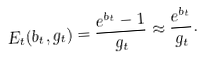<formula> <loc_0><loc_0><loc_500><loc_500>E _ { t } ( b _ { t } , g _ { t } ) = \frac { e ^ { b _ { t } } - 1 } { g _ { t } } \approx \frac { e ^ { b _ { t } } } { g _ { t } } .</formula> 